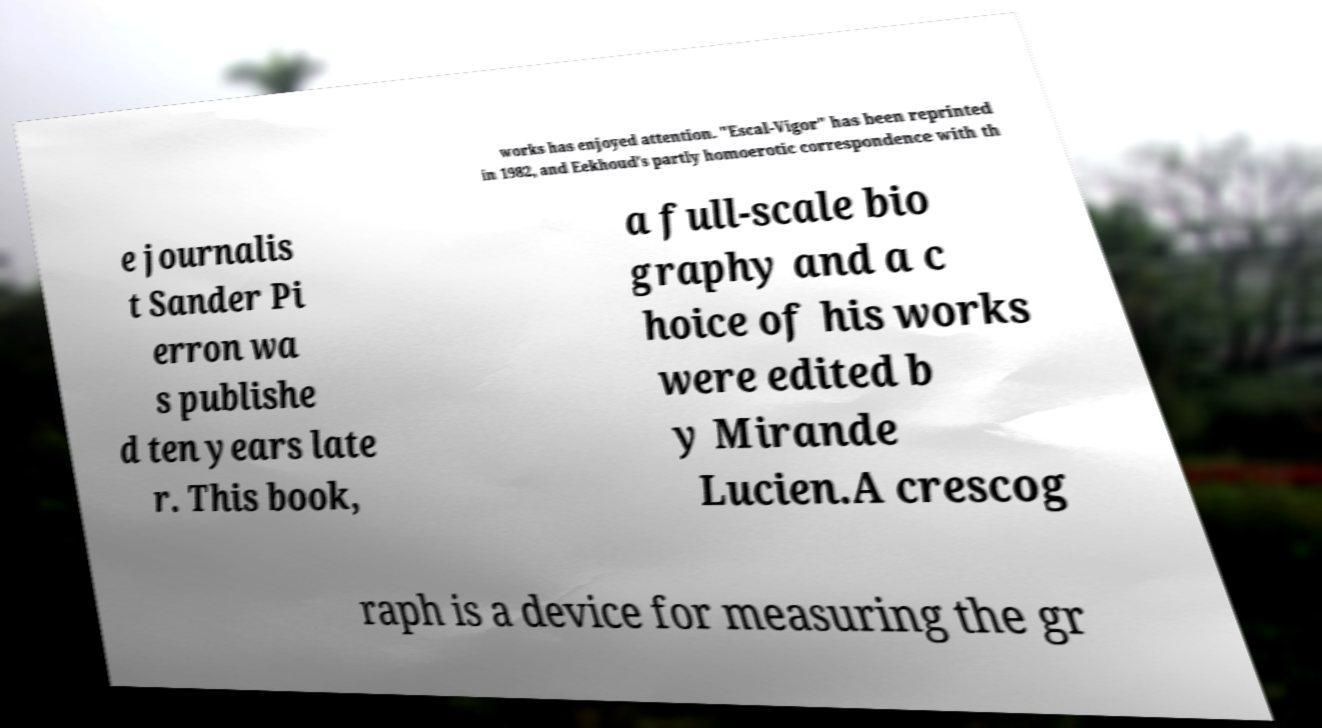There's text embedded in this image that I need extracted. Can you transcribe it verbatim? works has enjoyed attention. "Escal-Vigor" has been reprinted in 1982, and Eekhoud's partly homoerotic correspondence with th e journalis t Sander Pi erron wa s publishe d ten years late r. This book, a full-scale bio graphy and a c hoice of his works were edited b y Mirande Lucien.A crescog raph is a device for measuring the gr 